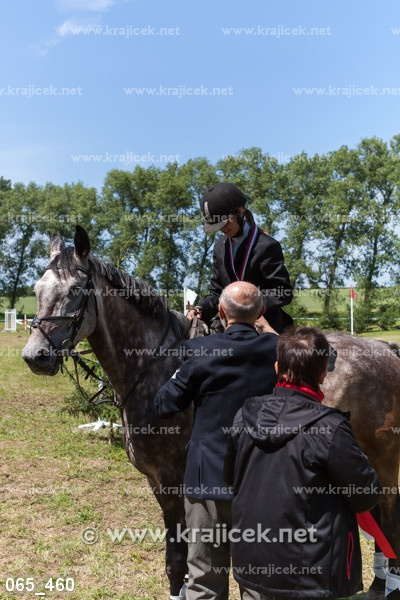Describe the objects in this image and their specific colors. I can see horse in lightblue, black, gray, and darkgray tones, people in lightblue, black, gray, and maroon tones, people in lightblue, black, gray, and darkgray tones, and people in lightblue, black, gray, and maroon tones in this image. 